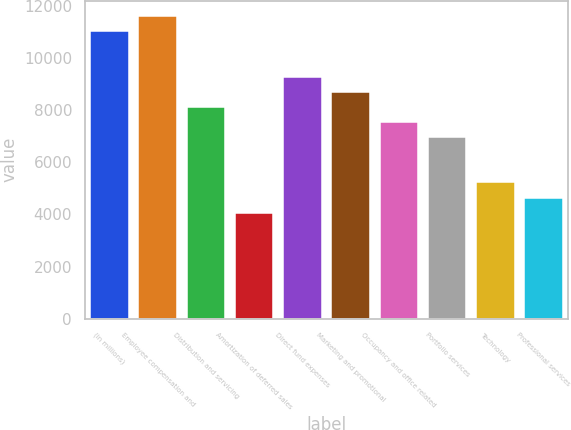Convert chart. <chart><loc_0><loc_0><loc_500><loc_500><bar_chart><fcel>(in millions)<fcel>Employee compensation and<fcel>Distribution and servicing<fcel>Amortization of deferred sales<fcel>Direct fund expenses<fcel>Marketing and promotional<fcel>Occupancy and office related<fcel>Portfolio services<fcel>Technology<fcel>Professional services<nl><fcel>11039.3<fcel>11620<fcel>8135.8<fcel>4070.9<fcel>9297.2<fcel>8716.5<fcel>7555.1<fcel>6974.4<fcel>5232.3<fcel>4651.6<nl></chart> 